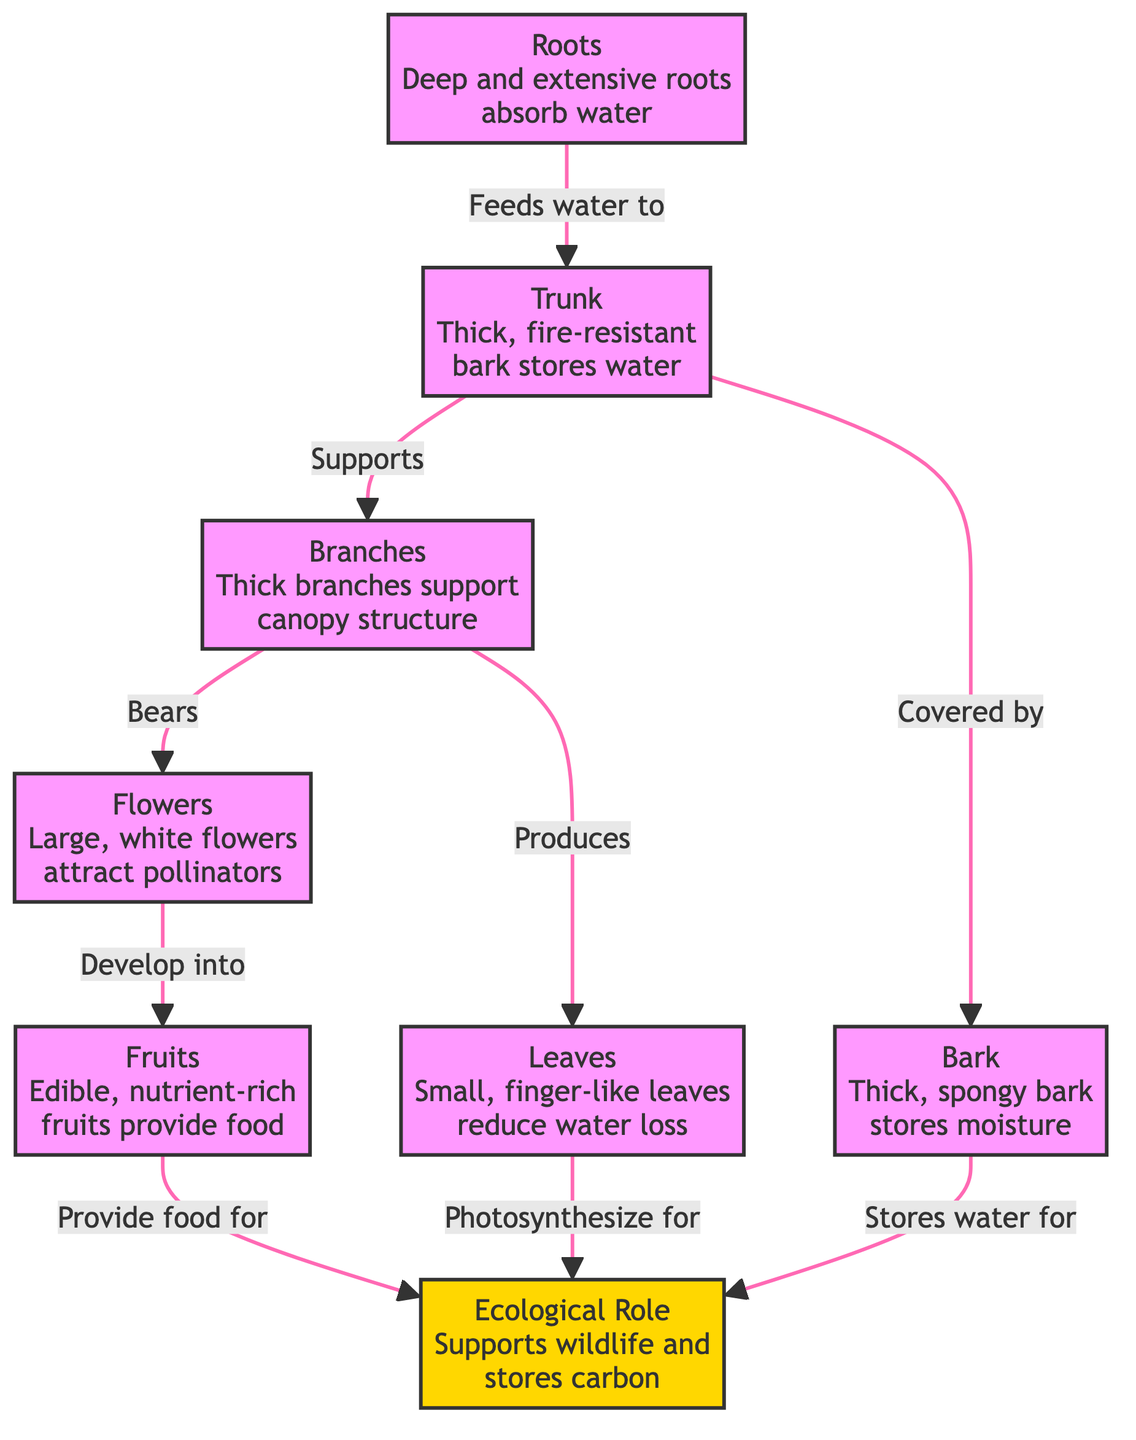What does the trunk store? The trunk is noted to store water according to the diagram. This is derived from the information that specifically states "Thick, fire-resistant bark stores water" leading us to conclude that the trunk plays a role in water storage.
Answer: water How are the deep roots beneficial? The diagram mentions that deep and extensive roots absorb water, indicating their importance in accessing moisture from the ground. This highlights the adaptation of the roots to gather vital resources.
Answer: absorb water How many types of adaptations are shown? The diagram presents several key adaptations of the baobab tree: trunk, leaves, flowers, fruits, roots, bark, and branches. Counting these distinct components shows that there are seven adaptations illustrated in the diagram.
Answer: 7 What do the large white flowers attract? The relationship defined in the diagram states that the large, white flowers "attract pollinators." This means that the role of the flowers is specifically to draw in these organisms.
Answer: pollinators Which part of the tree bears the edible products? The diagram indicates that the fruits develop from the flowers, thus making the fruits the part of the tree that bears the nutrient-rich, edible products. This clearly points out the fruits' significance.
Answer: fruits What ecological role does the bark play? According to the diagram, the bark stores water that contributes to the ecological role of supporting wildlife and storing carbon. Therefore, the bark's contribution is essential in this ecological context.
Answer: stores moisture What connects branches to leaves? The diagram shows that branches produce leaves, establishing a direct relationship between these two components of the tree. This means that the branches physically and functionally connect with the leaves by producing them.
Answer: produces What aspect supports wildlife? The ecological role section of the diagram states, “Supports wildlife,” which is a key function of the tree within its ecosystem. This clearly identifies that several elements, including fruits and leaves, contribute towards this role.
Answer: supports wildlife 